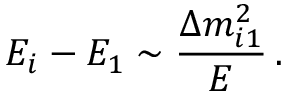<formula> <loc_0><loc_0><loc_500><loc_500>E _ { i } - E _ { 1 } \sim \frac { \Delta { m } _ { i 1 } ^ { 2 } } { E } \, .</formula> 